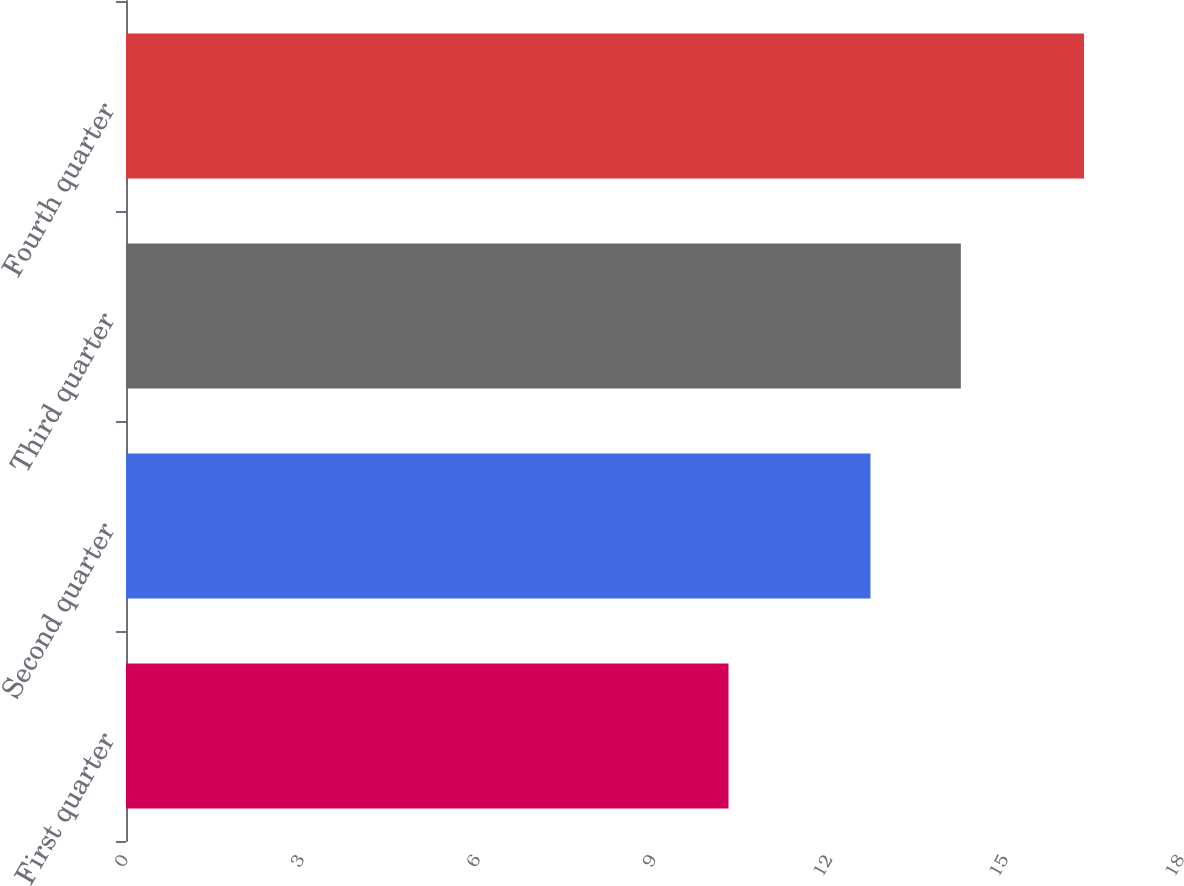<chart> <loc_0><loc_0><loc_500><loc_500><bar_chart><fcel>First quarter<fcel>Second quarter<fcel>Third quarter<fcel>Fourth quarter<nl><fcel>10.27<fcel>12.69<fcel>14.23<fcel>16.33<nl></chart> 